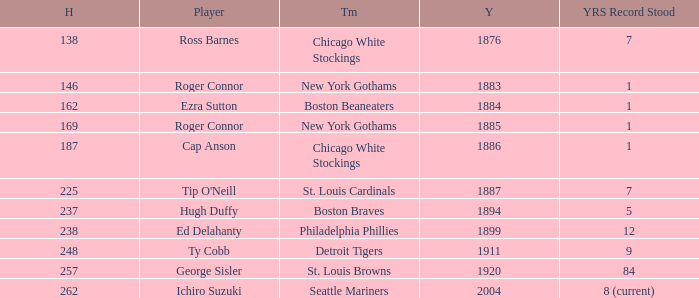Name the hits for years before 1883 138.0. 